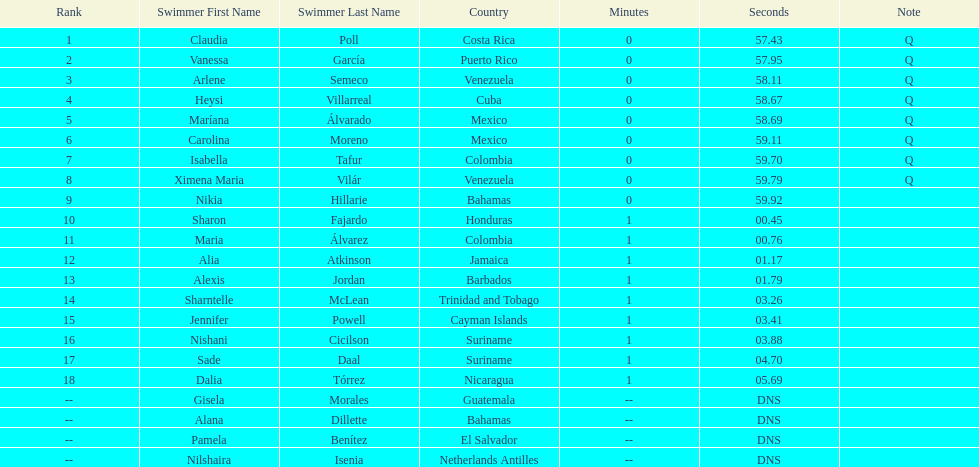Who was the last competitor to actually finish the preliminaries? Dalia Tórrez. 